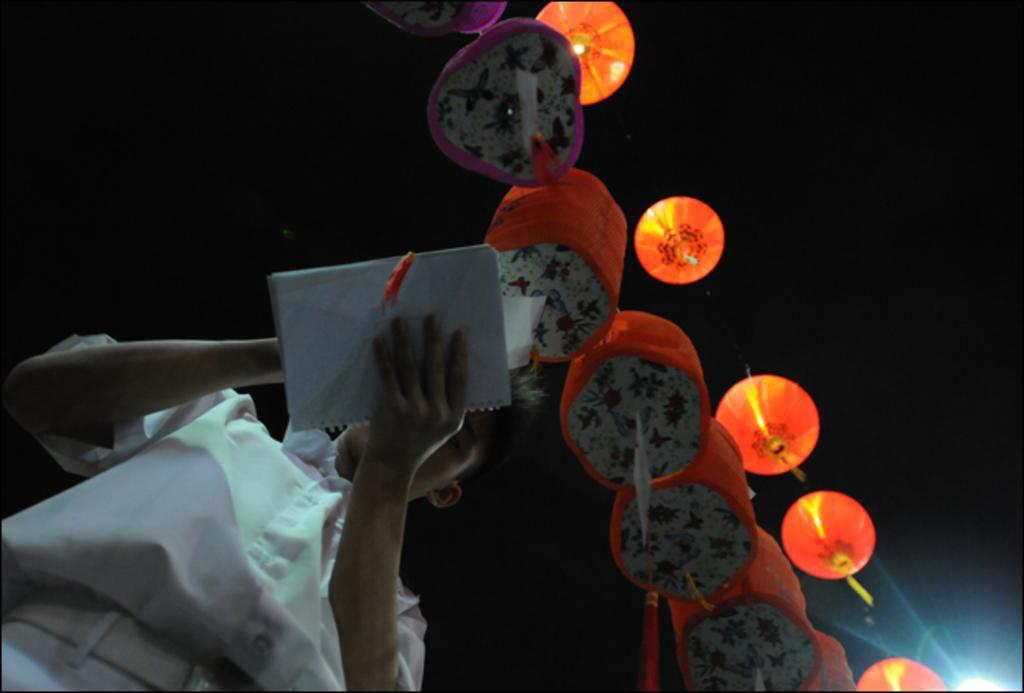In one or two sentences, can you explain what this image depicts? In this image I can see a person holding a book visible at bottom and person wearing a white color shirt , in the middle I can see colorful paper lantern and light focus at bottom on the right side and background is very dark. 